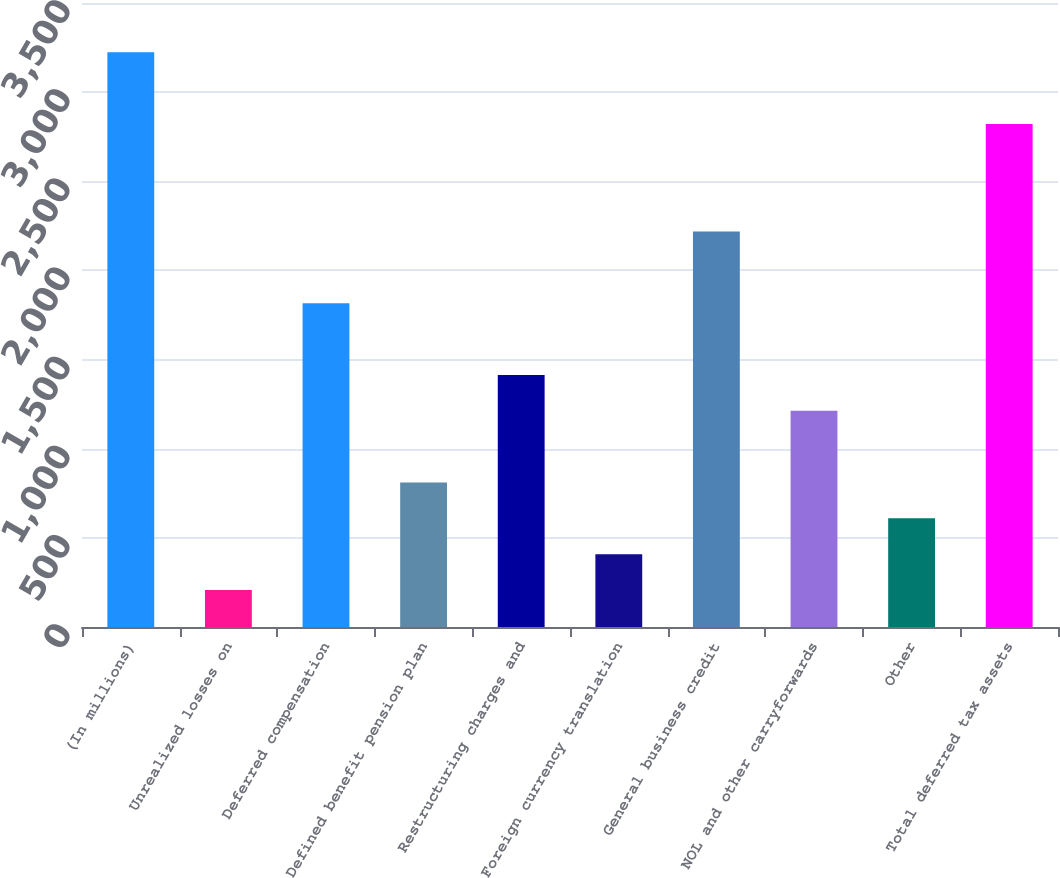Convert chart. <chart><loc_0><loc_0><loc_500><loc_500><bar_chart><fcel>(In millions)<fcel>Unrealized losses on<fcel>Deferred compensation<fcel>Defined benefit pension plan<fcel>Restructuring charges and<fcel>Foreign currency translation<fcel>General business credit<fcel>NOL and other carryforwards<fcel>Other<fcel>Total deferred tax assets<nl><fcel>3223.6<fcel>207.1<fcel>1815.9<fcel>810.4<fcel>1413.7<fcel>408.2<fcel>2218.1<fcel>1212.6<fcel>609.3<fcel>2821.4<nl></chart> 